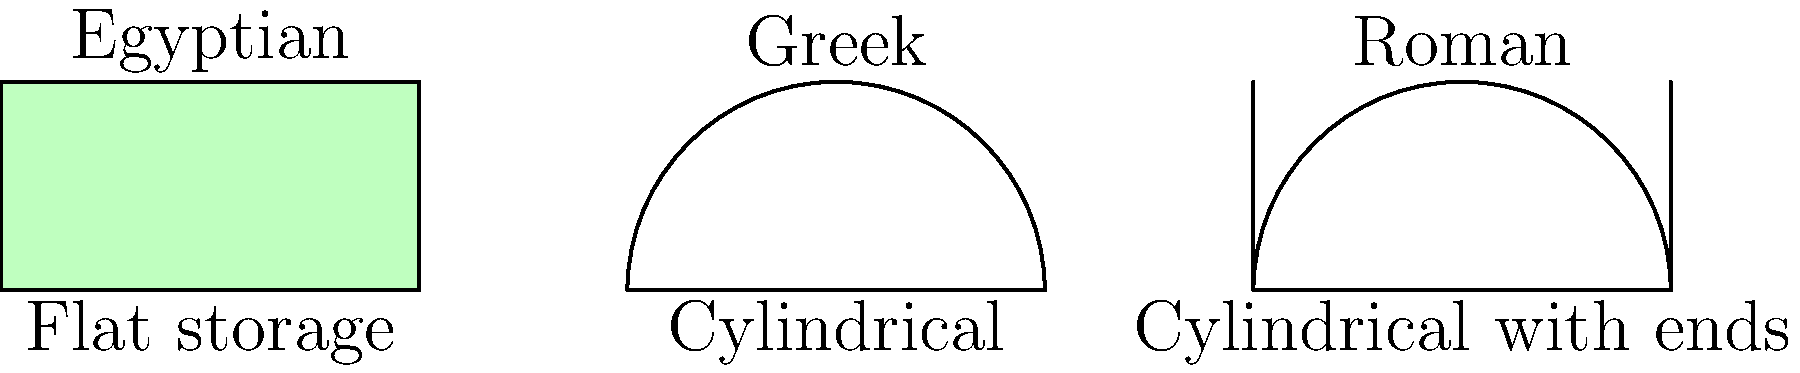Compare the scroll storage methods illustrated in the cross-sectional diagrams for Egyptian, Greek, and Roman civilizations. Which method potentially offered the best protection against environmental factors, and why? To answer this question, let's analyze each storage method:

1. Egyptian method:
   - Flat storage
   - Scrolls laid horizontally
   - No rolling or cylindrical shape

2. Greek method:
   - Cylindrical storage
   - Scrolls rolled into a cylinder
   - Open ends

3. Roman method:
   - Cylindrical storage with closed ends
   - Scrolls rolled into a cylinder
   - Protective end caps or closures

Step-by-step analysis:

1. Protection from dust and debris:
   - Egyptian: Limited protection, as the flat surface can collect dust
   - Greek: Better protection, as the cylindrical shape reduces exposed surface area
   - Roman: Best protection, as the closed ends prevent dust from entering

2. Protection from physical damage:
   - Egyptian: Vulnerable to bending and creasing
   - Greek: Better protection against bending, but scroll ends are exposed
   - Roman: Best protection, as the entire scroll is enclosed

3. Climate control:
   - Egyptian: Limited control, as the entire scroll is exposed to ambient conditions
   - Greek: Some improvement, as the rolled shape reduces exposure
   - Roman: Best climate control, as the closed ends create a more stable microenvironment

4. Ease of access:
   - Egyptian: Easy access, but potentially more handling required
   - Greek: Good balance between protection and accessibility
   - Roman: Most protected, but slightly less convenient to access

5. Space efficiency:
   - Egyptian: Least space-efficient
   - Greek and Roman: More space-efficient due to cylindrical shape

Considering these factors, the Roman method potentially offered the best protection against environmental factors. The combination of cylindrical shape and closed ends provided superior defense against dust, physical damage, and climate fluctuations while maintaining reasonable accessibility and space efficiency.
Answer: Roman method (cylindrical with closed ends) 